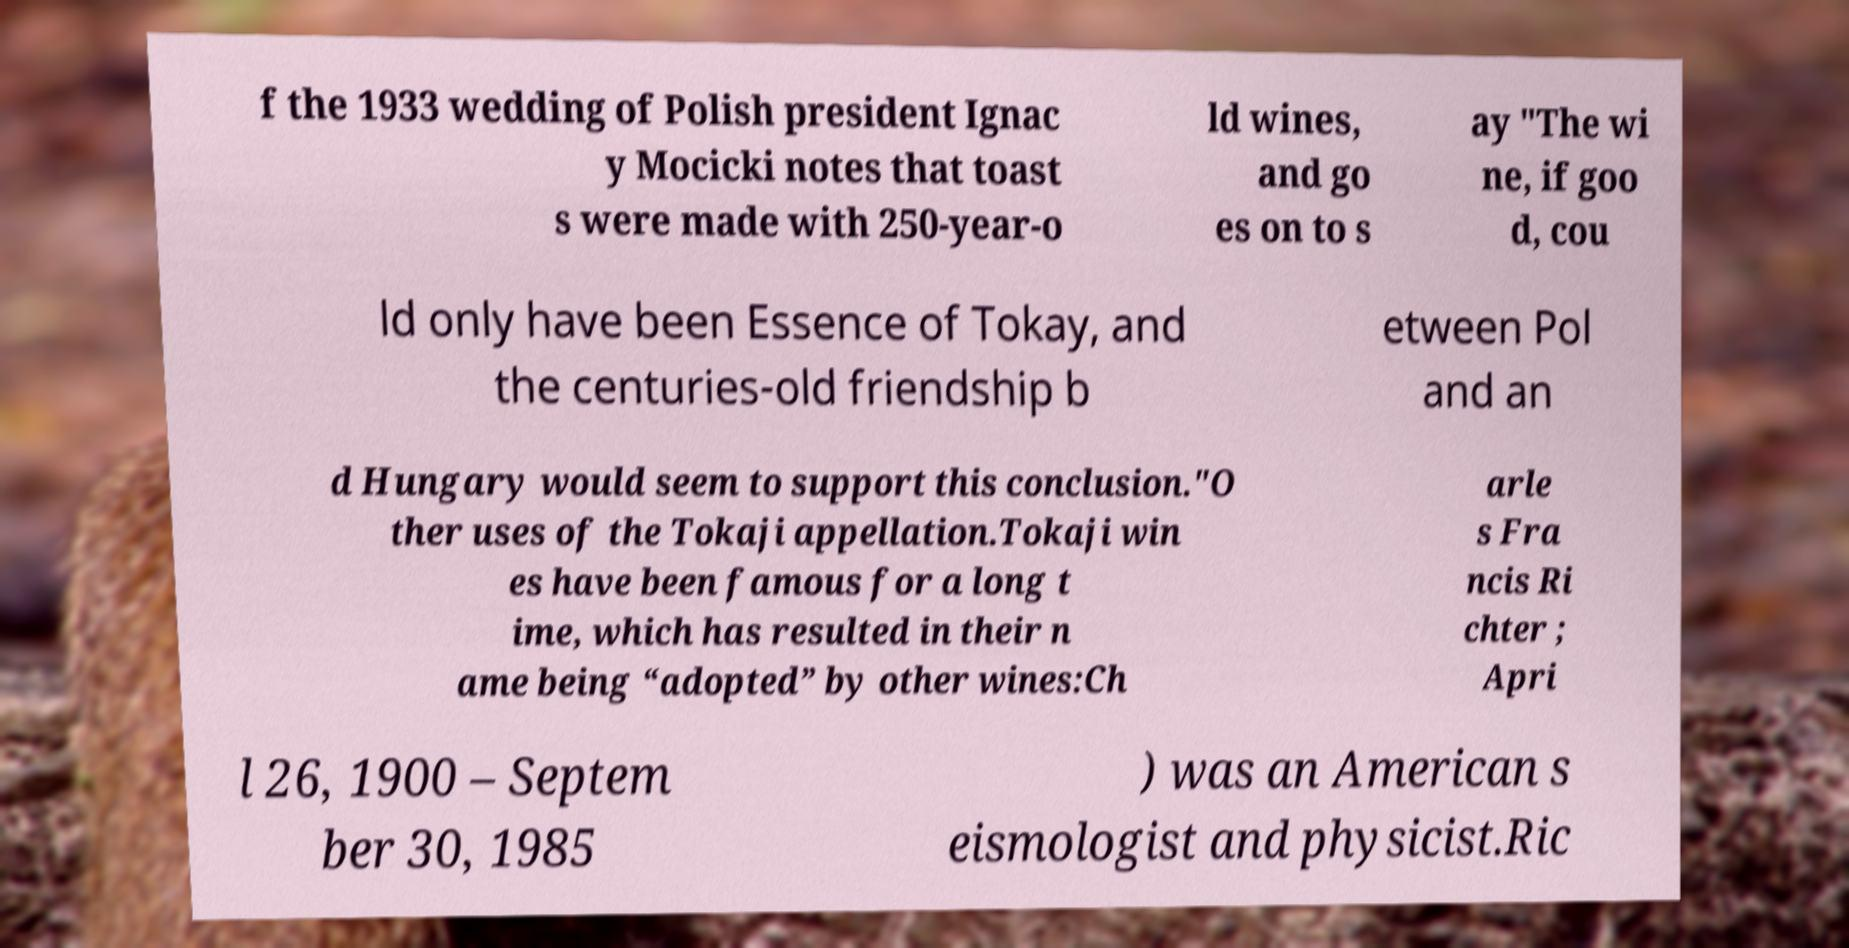Could you extract and type out the text from this image? f the 1933 wedding of Polish president Ignac y Mocicki notes that toast s were made with 250-year-o ld wines, and go es on to s ay "The wi ne, if goo d, cou ld only have been Essence of Tokay, and the centuries-old friendship b etween Pol and an d Hungary would seem to support this conclusion."O ther uses of the Tokaji appellation.Tokaji win es have been famous for a long t ime, which has resulted in their n ame being “adopted” by other wines:Ch arle s Fra ncis Ri chter ; Apri l 26, 1900 – Septem ber 30, 1985 ) was an American s eismologist and physicist.Ric 